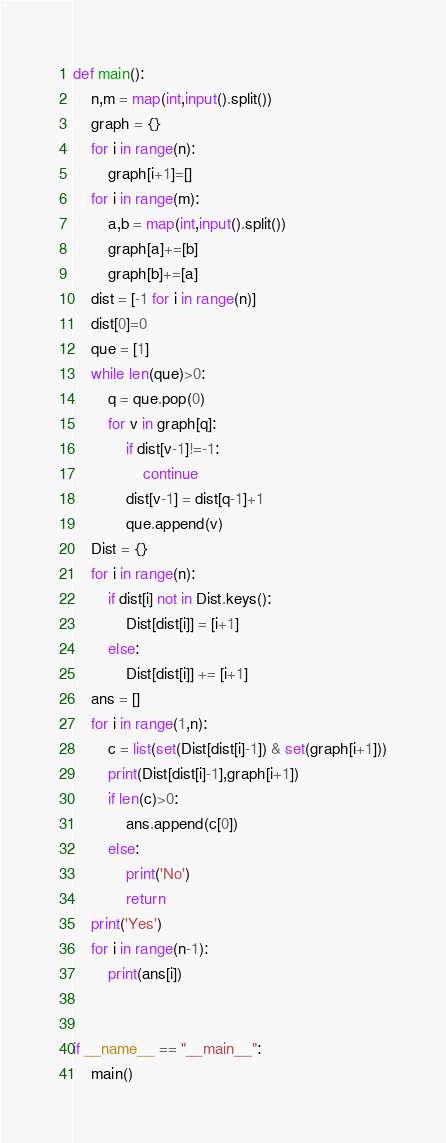Convert code to text. <code><loc_0><loc_0><loc_500><loc_500><_Python_>def main():
    n,m = map(int,input().split())
    graph = {}
    for i in range(n):
        graph[i+1]=[]
    for i in range(m):
        a,b = map(int,input().split())
        graph[a]+=[b]
        graph[b]+=[a]
    dist = [-1 for i in range(n)]
    dist[0]=0
    que = [1]
    while len(que)>0:
        q = que.pop(0)
        for v in graph[q]:
            if dist[v-1]!=-1:
                continue
            dist[v-1] = dist[q-1]+1
            que.append(v)
    Dist = {}
    for i in range(n):
        if dist[i] not in Dist.keys():
            Dist[dist[i]] = [i+1]
        else:
            Dist[dist[i]] += [i+1]
    ans = []
    for i in range(1,n):
        c = list(set(Dist[dist[i]-1]) & set(graph[i+1]))
        print(Dist[dist[i]-1],graph[i+1])
        if len(c)>0:
            ans.append(c[0])
        else:
            print('No')
            return
    print('Yes')
    for i in range(n-1):
        print(ans[i])


if __name__ == "__main__":
    main()
</code> 